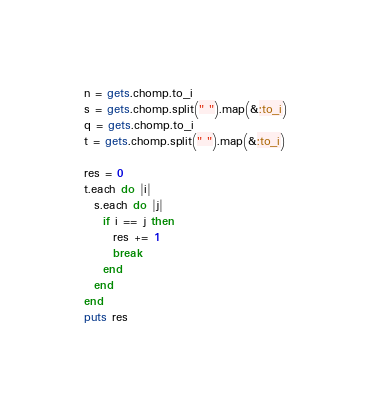Convert code to text. <code><loc_0><loc_0><loc_500><loc_500><_Ruby_>n = gets.chomp.to_i
s = gets.chomp.split(" ").map(&:to_i)
q = gets.chomp.to_i
t = gets.chomp.split(" ").map(&:to_i)

res = 0
t.each do |i|
  s.each do |j|
    if i == j then
      res += 1
      break
    end
  end
end
puts res</code> 